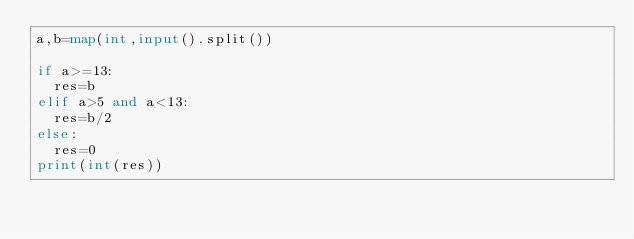Convert code to text. <code><loc_0><loc_0><loc_500><loc_500><_Python_>a,b=map(int,input().split())

if a>=13:
  res=b
elif a>5 and a<13:
  res=b/2
else:
  res=0
print(int(res))</code> 